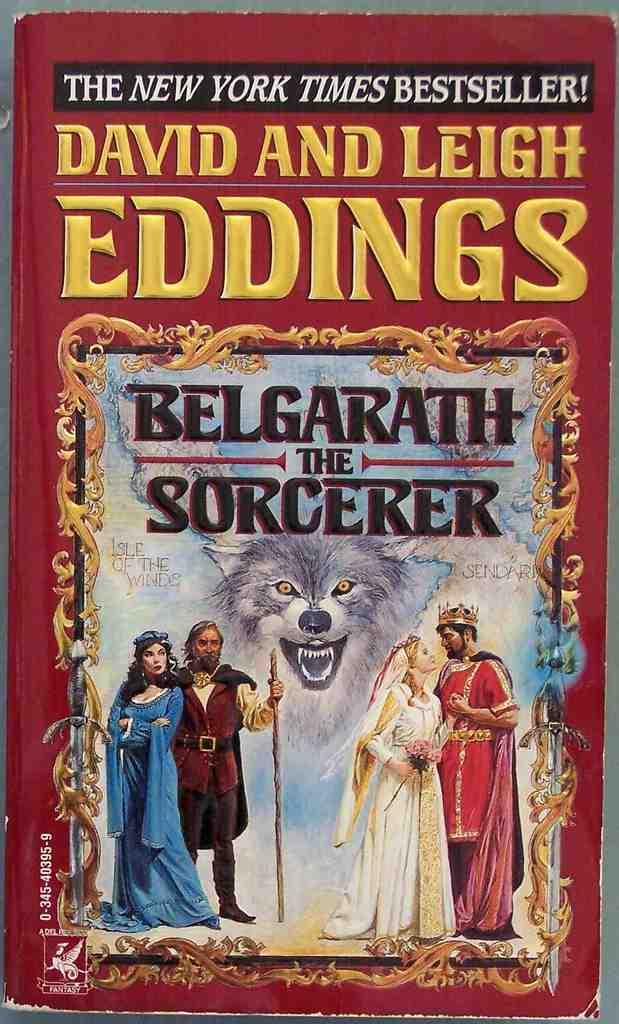Who are the authors of this book?
Offer a terse response. David and leigh eddings. 